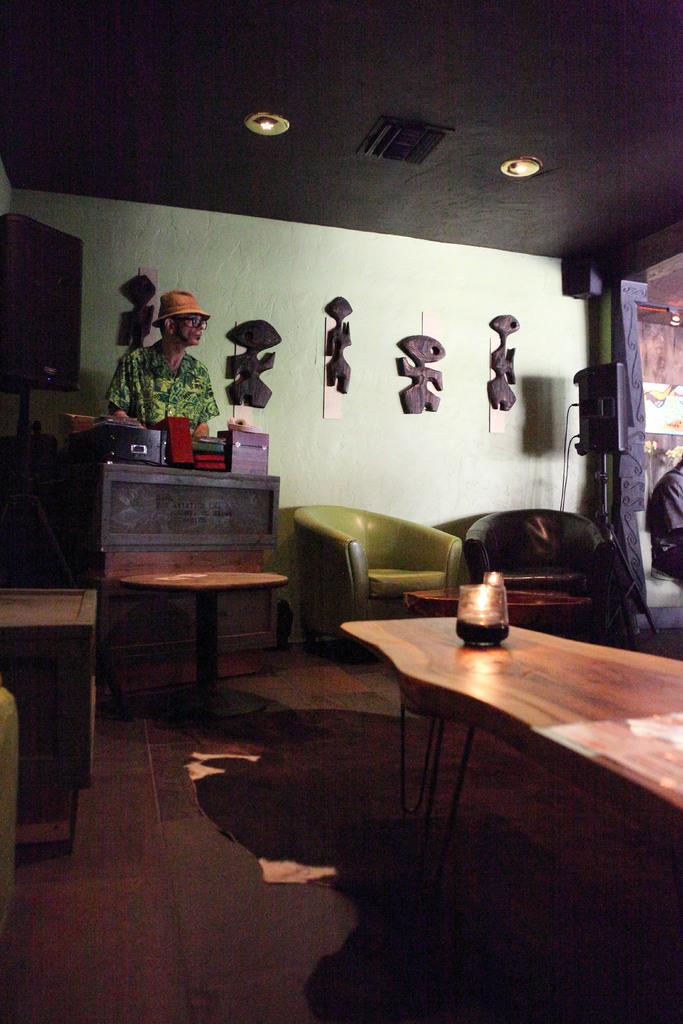How would you summarize this image in a sentence or two? This is the picture taken in a room, the man in floral shirt was standing on floor. In front of the man there is a table on the table there are some items and also on the floor there is other table on top of the table there is a glass lamp and chairs. behind the man there is a wall with decorative items and there is a ceiling lights on the top. 